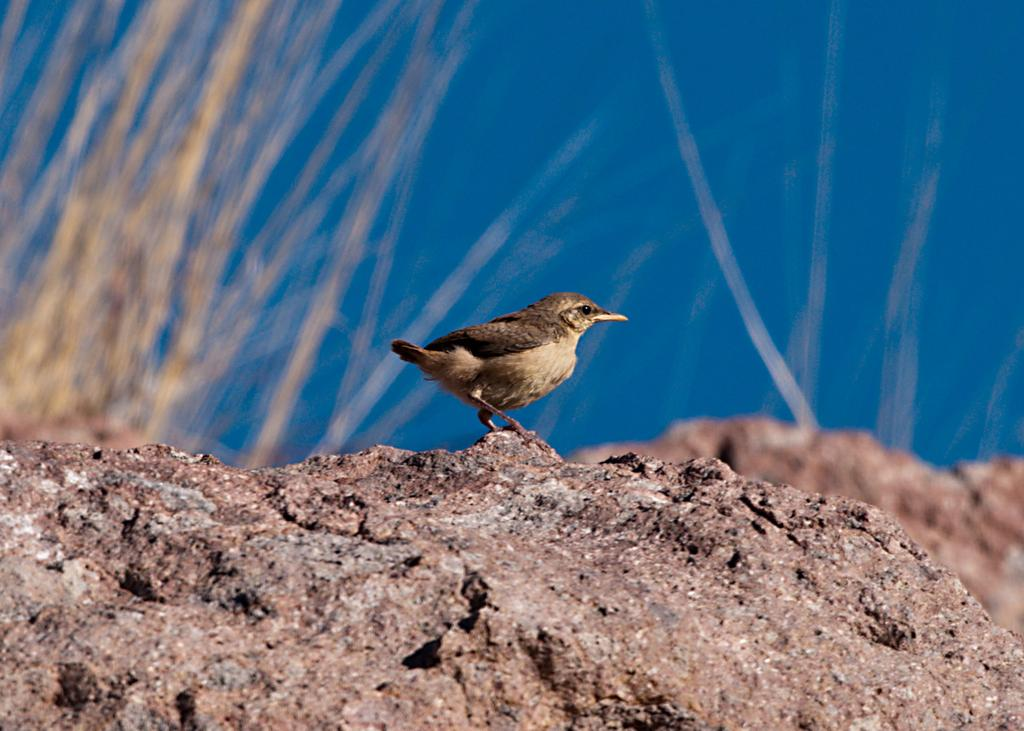What type of animal is in the image? There is a bird in the image. What is the bird standing on? The bird is standing on a stone. What can be seen in the background of the image? There is grass and the sky visible in the background of the image. What type of hose is the bird using to cry in the image? There is no hose or crying bird present in the image; it features a bird standing on a stone with grass and the sky visible in the background. 